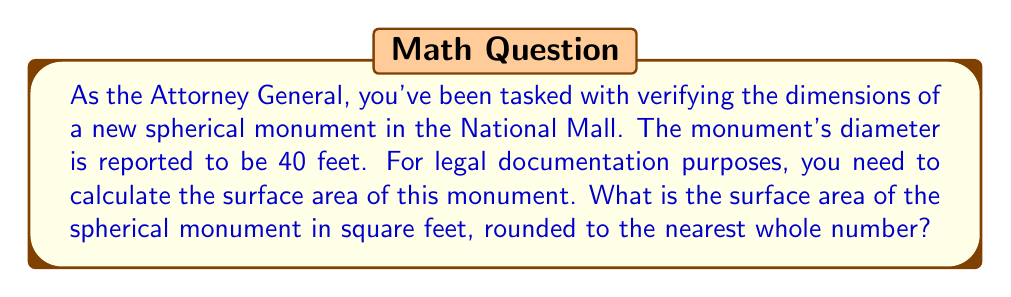Solve this math problem. To solve this problem, we'll use the formula for the surface area of a sphere and follow these steps:

1. The formula for the surface area of a sphere is:
   $$A = 4\pi r^2$$
   where $A$ is the surface area and $r$ is the radius of the sphere.

2. We're given the diameter of 40 feet. The radius is half of the diameter:
   $$r = \frac{40}{2} = 20\text{ feet}$$

3. Now we can substitute this into our formula:
   $$A = 4\pi (20)^2$$

4. Simplify:
   $$A = 4\pi (400)$$
   $$A = 1600\pi$$

5. Calculate the result:
   $$A \approx 5026.55\text{ square feet}$$

6. Rounding to the nearest whole number:
   $$A \approx 5027\text{ square feet}$$

[asy]
import geometry;

size(200);
draw(circle((0,0),1), blue);
dot((0,0), blue);
draw((0,0)--(1,0), blue, Arrow);
label("r", (0.5,0.1), blue);
label("Spherical Monument", (0,-1.3), blue);
[/asy]
Answer: The surface area of the spherical monument is approximately 5027 square feet. 